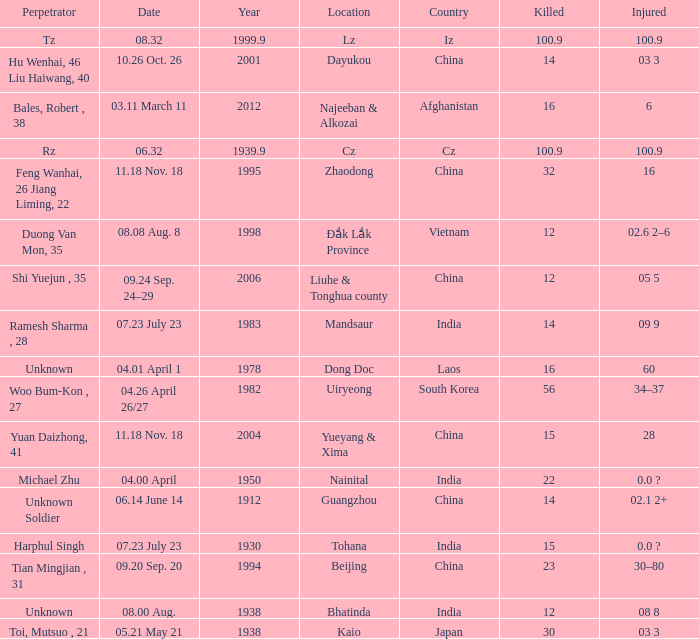What is Injured, when Country is "Afghanistan"? 6.0. 